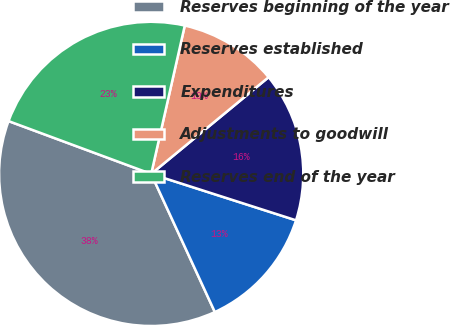<chart> <loc_0><loc_0><loc_500><loc_500><pie_chart><fcel>Reserves beginning of the year<fcel>Reserves established<fcel>Expenditures<fcel>Adjustments to goodwill<fcel>Reserves end of the year<nl><fcel>37.52%<fcel>13.19%<fcel>15.9%<fcel>10.49%<fcel>22.9%<nl></chart> 